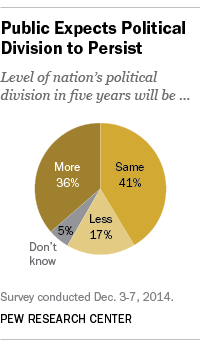Outline some significant characteristics in this image. The pie graph shows that a color that represents 5% of the total is gray. The difference in value between "Same" and the sum of "More" and "Less" is 12. 